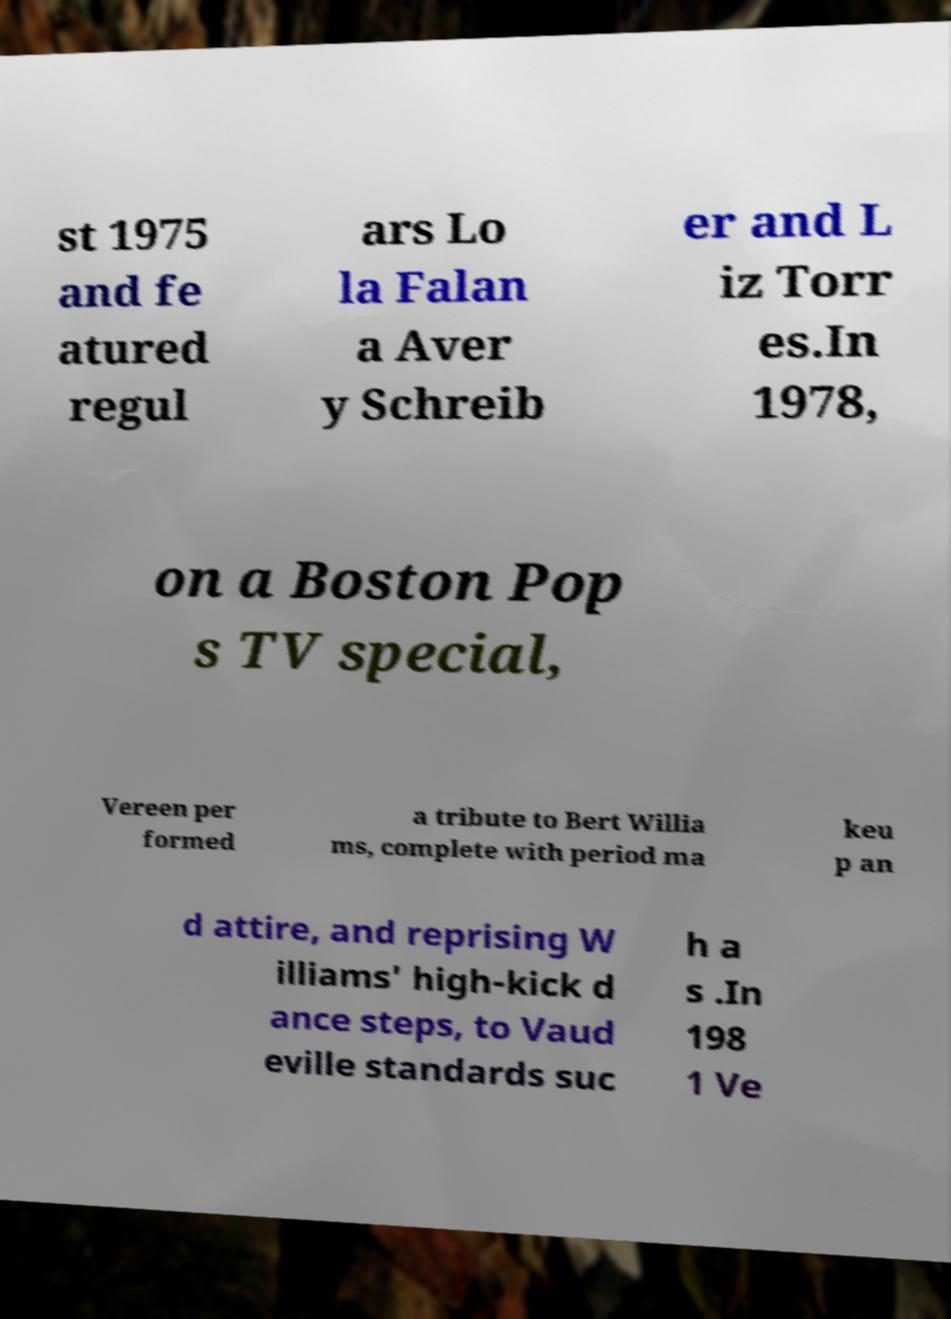For documentation purposes, I need the text within this image transcribed. Could you provide that? st 1975 and fe atured regul ars Lo la Falan a Aver y Schreib er and L iz Torr es.In 1978, on a Boston Pop s TV special, Vereen per formed a tribute to Bert Willia ms, complete with period ma keu p an d attire, and reprising W illiams' high-kick d ance steps, to Vaud eville standards suc h a s .In 198 1 Ve 